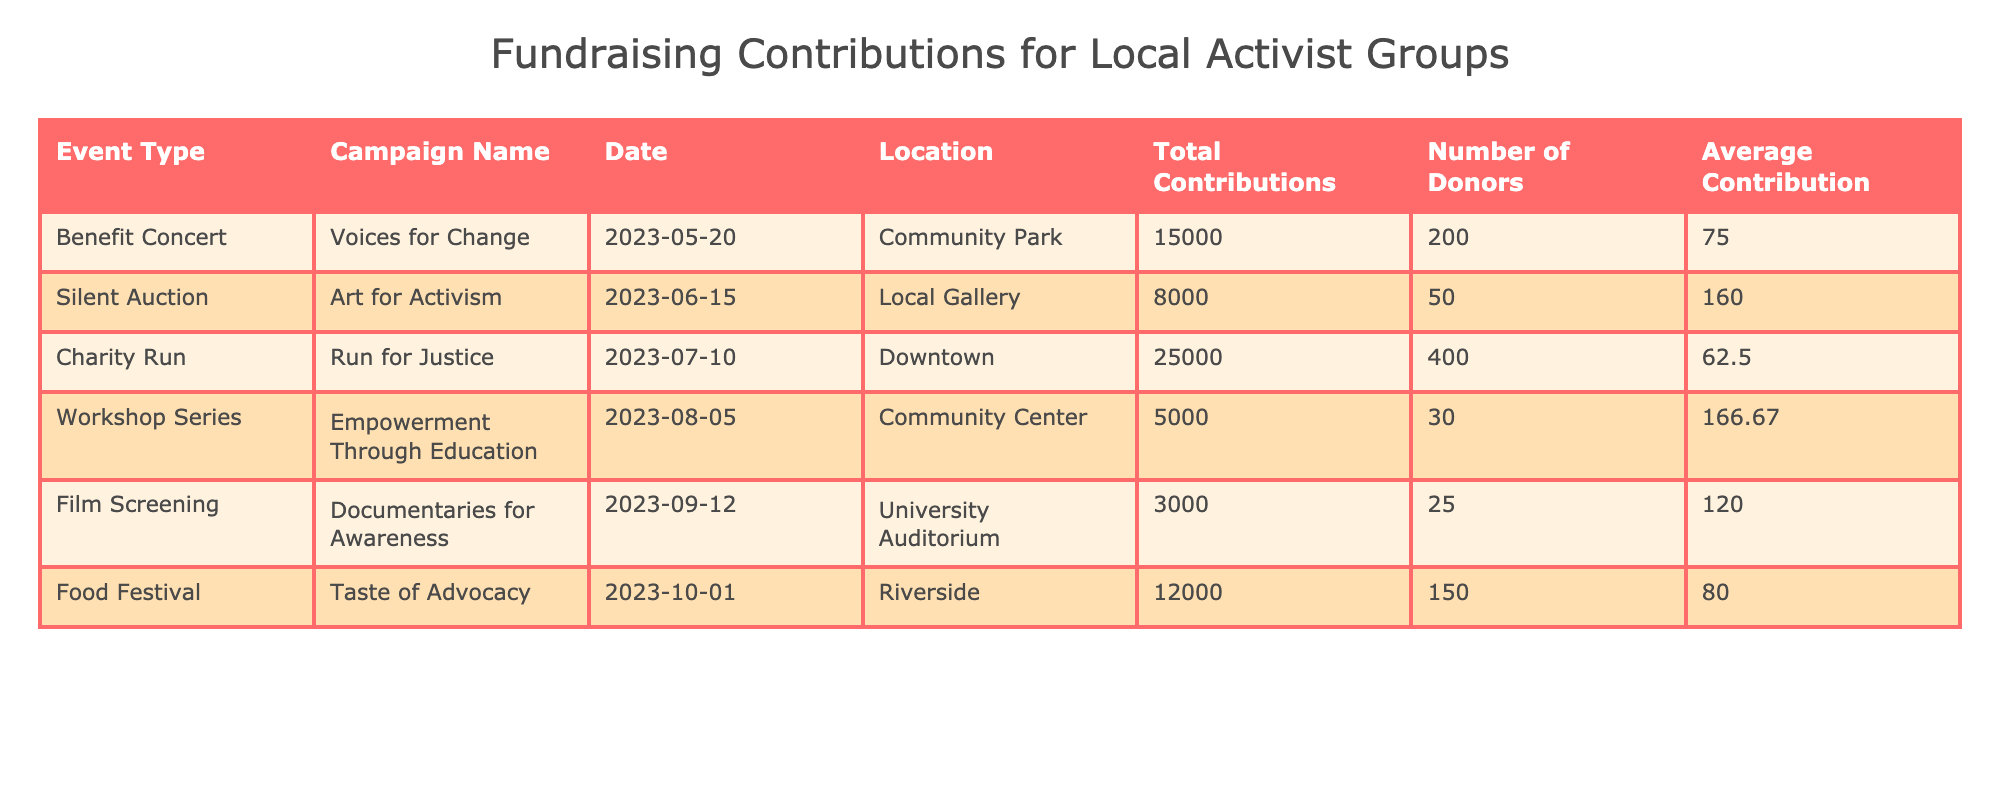What is the total contribution from the Charity Run event? From the table, the total contributions for the Charity Run event are listed as 25000.
Answer: 25000 How many donors contributed to the Food Festival? The table indicates that the Food Festival had a total of 150 donors.
Answer: 150 Which event type had the highest average contribution per donor? To find this, we can compare the average contributions listed: Benefit Concert (75), Silent Auction (160), Charity Run (62.5), Workshop Series (166.67), Film Screening (120), and Food Festival (80). The Workshop Series has the highest average contribution of 166.67.
Answer: Workshop Series Is the total contribution for the Silent Auction greater than that of the Film Screening? The total contribution for the Silent Auction is 8000, and for the Film Screening, it is 3000. Since 8000 is greater than 3000, the statement is true.
Answer: Yes What is the combined total contributions of all events listed? To find the combined total contributions, we add all the individual totals: 15000 (Benefit Concert) + 8000 (Silent Auction) + 25000 (Charity Run) + 5000 (Workshop Series) + 3000 (Film Screening) + 12000 (Food Festival) = 70000.
Answer: 70000 How many events had more than 100 total contributions? Looking at the table, the events are: Benefit Concert (200), Silent Auction (50), Charity Run (400), Workshop Series (30), Film Screening (25), and Food Festival (150). Only Benefit Concert, Charity Run, and Food Festival have more than 100 donors, totaling 3 events.
Answer: 3 What is the average total contribution across all events? To find the average, we first calculate the total contribution from all events which is 70000 and then divide by the number of events (6): 70000 / 6 = 11666.67.
Answer: 11666.67 Which campaign had the lowest number of donors? From the table, the number of donors for the events is: 200 (Benefit Concert), 50 (Silent Auction), 400 (Charity Run), 30 (Workshop Series), 25 (Film Screening), and 150 (Food Festival). The Film Screening had the lowest number of donors, which is 25.
Answer: Film Screening 